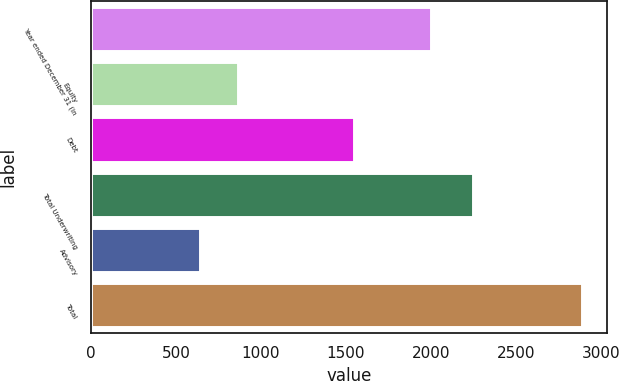<chart> <loc_0><loc_0><loc_500><loc_500><bar_chart><fcel>Year ended December 31 (in<fcel>Equity<fcel>Debt<fcel>Total Underwriting<fcel>Advisory<fcel>Total<nl><fcel>2003<fcel>866.8<fcel>1549<fcel>2248<fcel>642<fcel>2890<nl></chart> 